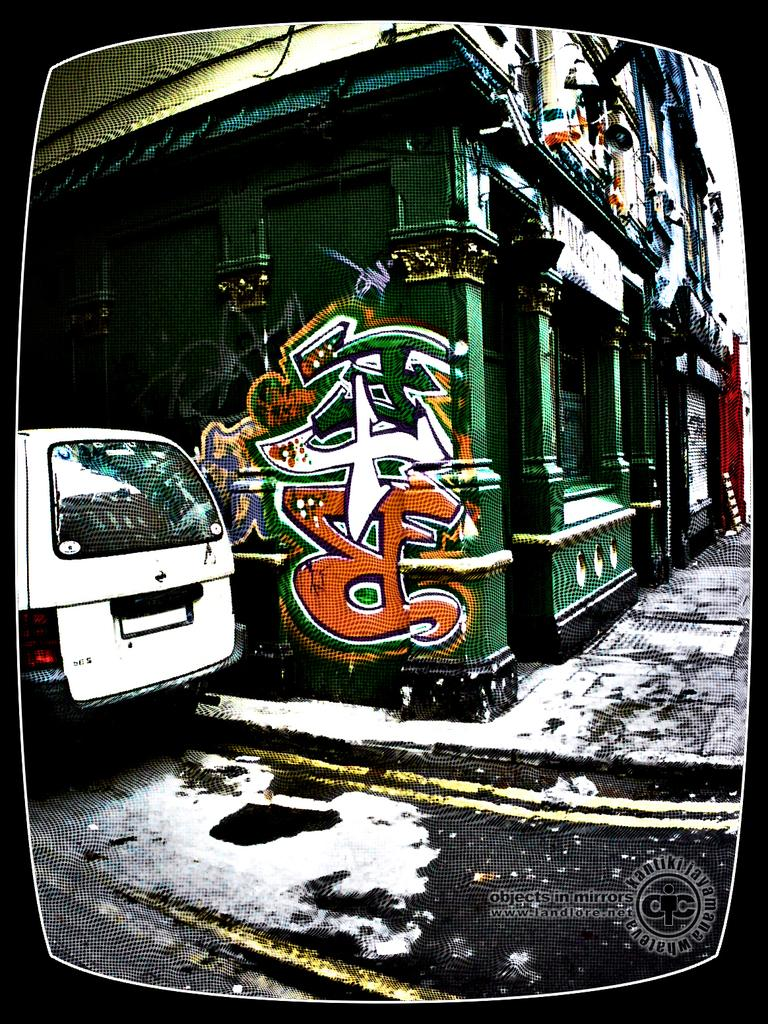What is on the road in the image? There is a vehicle on the road in the image. What is located next to the road in the image? There is a footpath in the image. What type of structure is visible in the image? There is a building with windows in the image. What decorative element is present on the building? There is a painting on the building. What type of pie is being served on the footpath in the image? There is no pie present in the image; it features a vehicle on the road, a footpath, a building with windows, and a painting on the building. How many roses can be seen growing on the footpath in the image? There are no roses visible in the image; it only features a vehicle on the road, a footpath, a building with windows, and a painting on the building. 